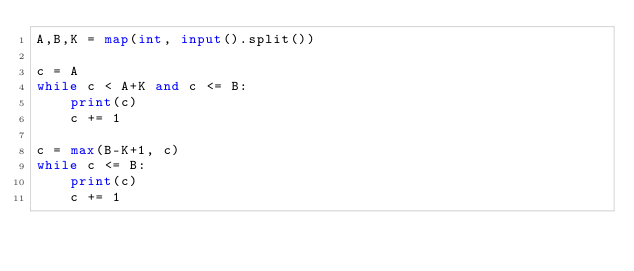Convert code to text. <code><loc_0><loc_0><loc_500><loc_500><_Python_>A,B,K = map(int, input().split())

c = A
while c < A+K and c <= B:
    print(c)
    c += 1

c = max(B-K+1, c)
while c <= B:
    print(c)
    c += 1</code> 